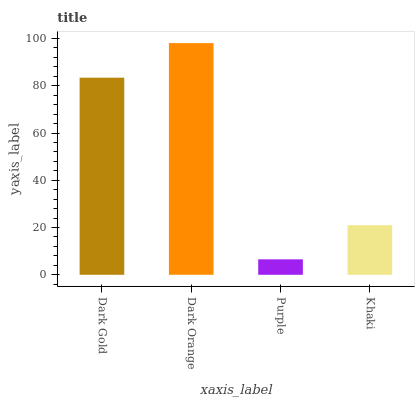Is Purple the minimum?
Answer yes or no. Yes. Is Dark Orange the maximum?
Answer yes or no. Yes. Is Dark Orange the minimum?
Answer yes or no. No. Is Purple the maximum?
Answer yes or no. No. Is Dark Orange greater than Purple?
Answer yes or no. Yes. Is Purple less than Dark Orange?
Answer yes or no. Yes. Is Purple greater than Dark Orange?
Answer yes or no. No. Is Dark Orange less than Purple?
Answer yes or no. No. Is Dark Gold the high median?
Answer yes or no. Yes. Is Khaki the low median?
Answer yes or no. Yes. Is Dark Orange the high median?
Answer yes or no. No. Is Dark Orange the low median?
Answer yes or no. No. 